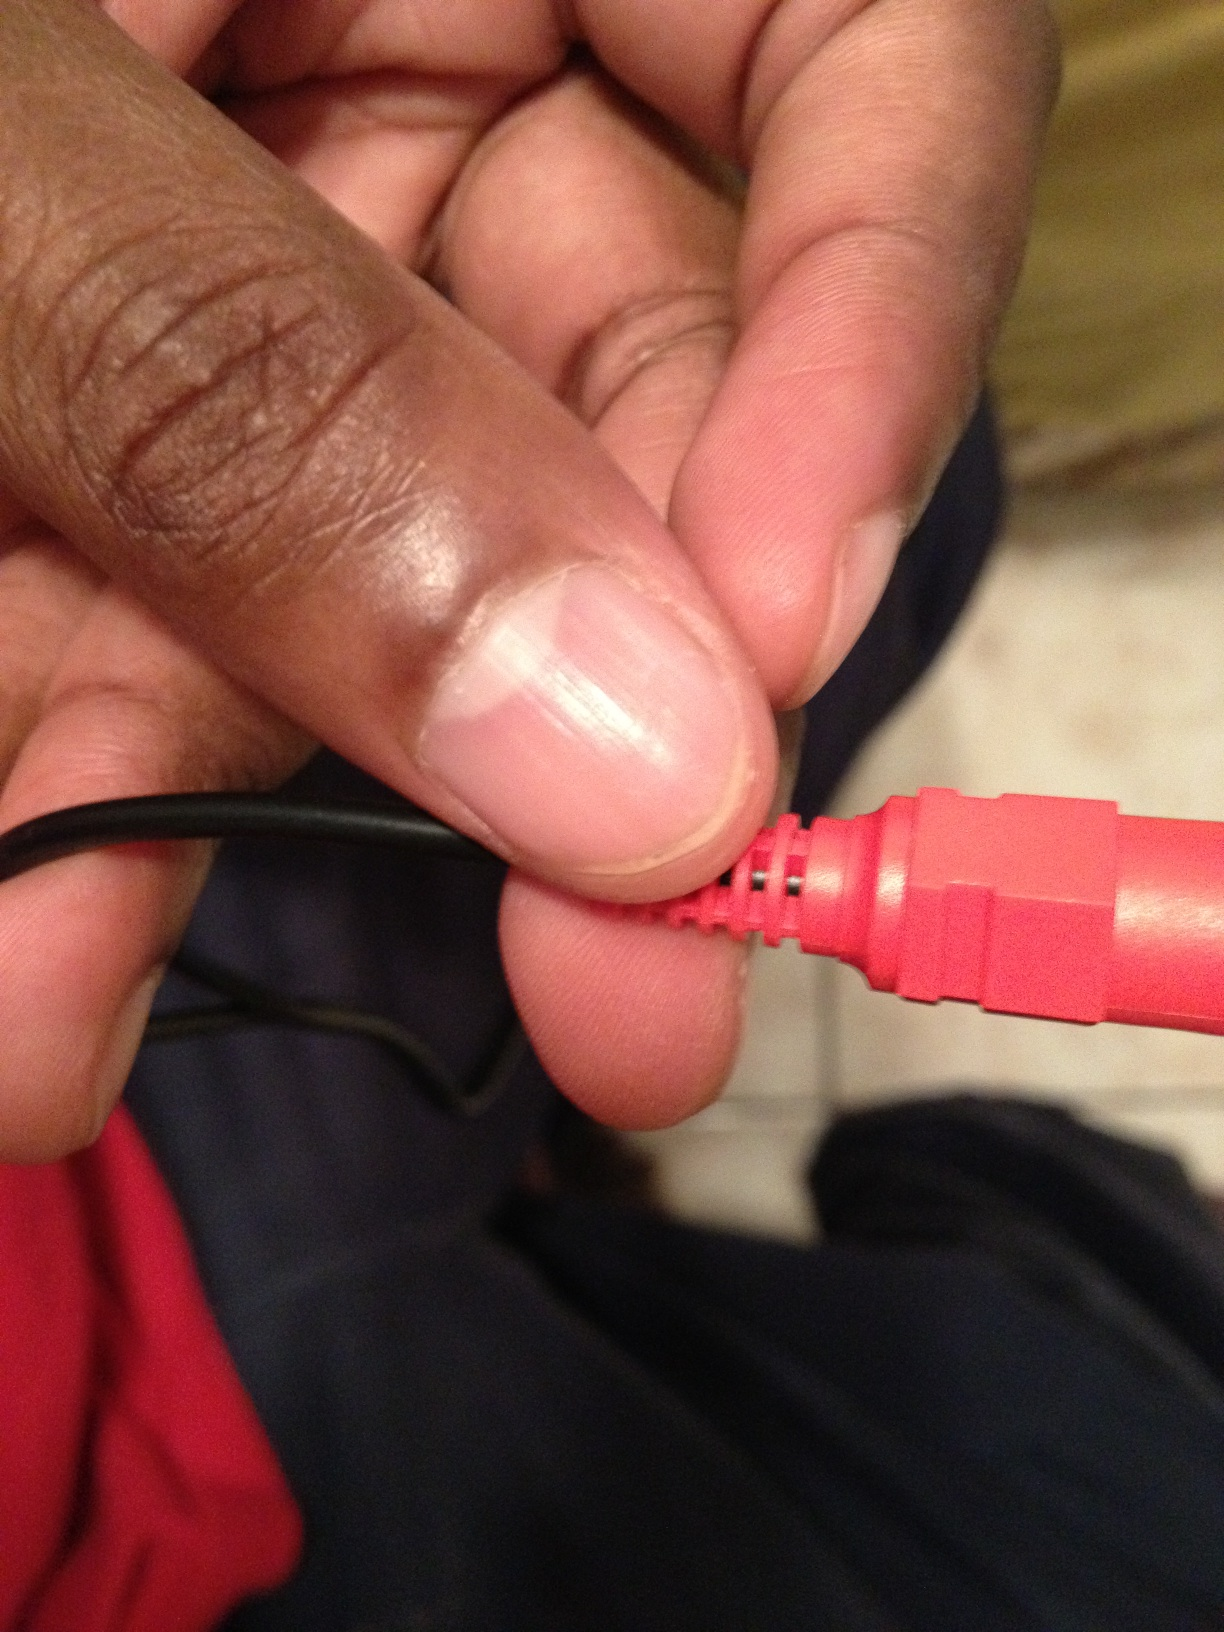Imagine this connector is part of a hidden system in a secret agent's gear. What function could it serve? In a secret agent's gear, this connector could be part of a covert surveillance system. It might connect a hidden microphone or camera to a secure communication device, enabling the agent to gather and transmit crucial information without detection. What other gadgets might accompany this connector in the agent's kit? The agent's kit could include a variety of advanced gadgets such as encrypted communication devices, compact drones for remote observation, multifunctional watches with built-in hacking tools, and hidden compartments for storing essential mission items like tranquilizers, GPS trackers, and emergency supplies. 